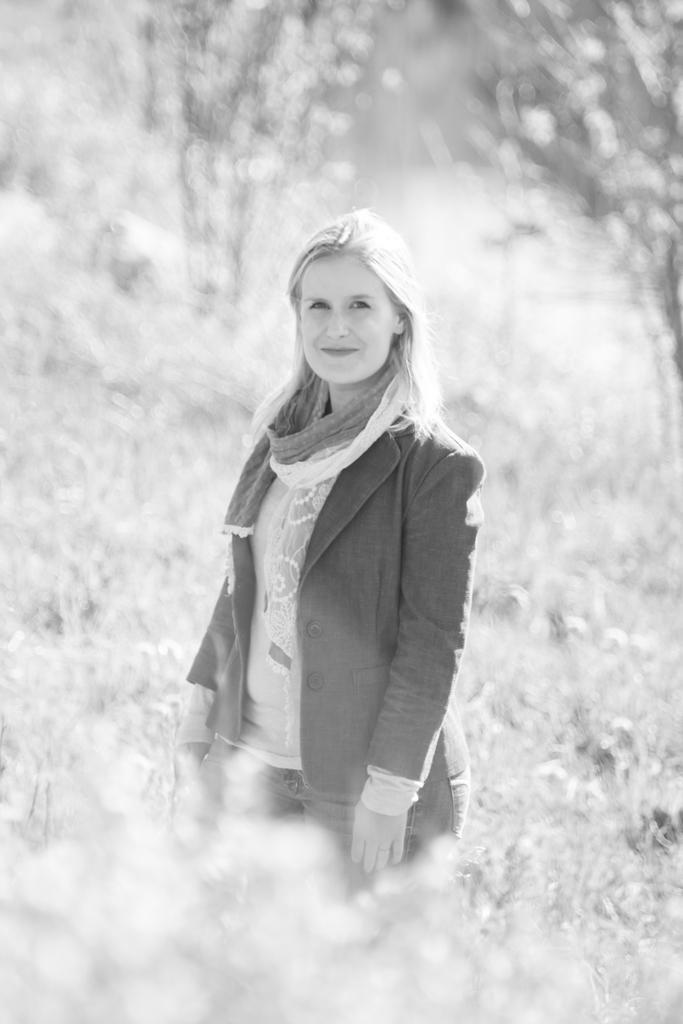Please provide a concise description of this image. This is a black and white picture, in this image we can see a woman standing on the ground, there are some plants and trees. 